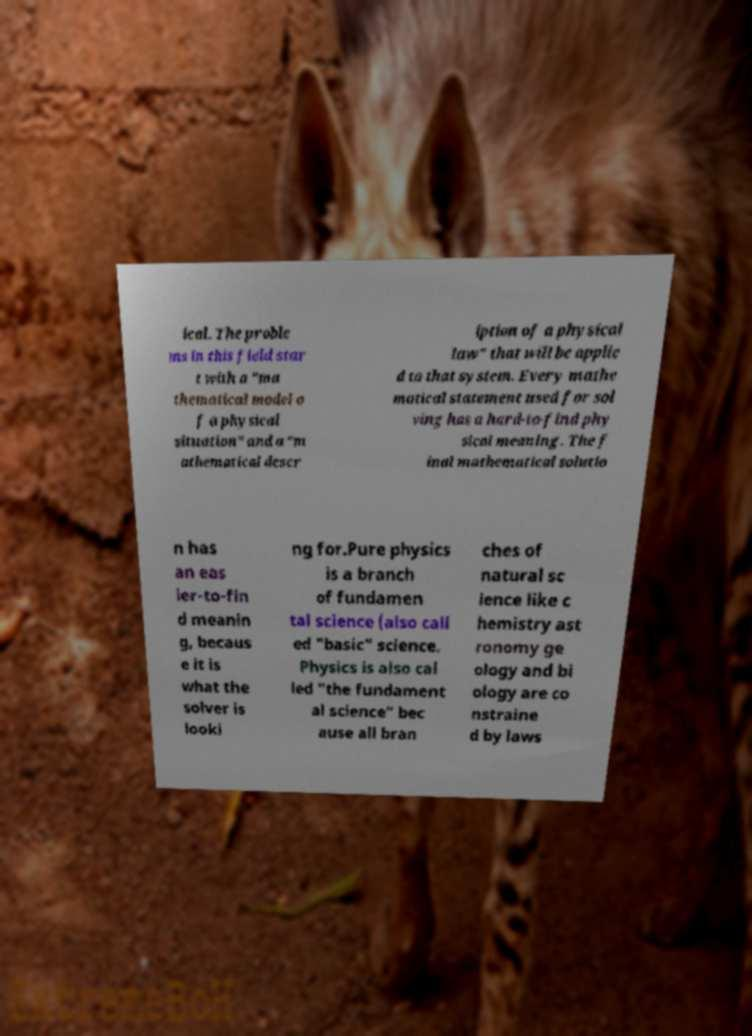Could you extract and type out the text from this image? ical. The proble ms in this field star t with a "ma thematical model o f a physical situation" and a "m athematical descr iption of a physical law" that will be applie d to that system. Every mathe matical statement used for sol ving has a hard-to-find phy sical meaning. The f inal mathematical solutio n has an eas ier-to-fin d meanin g, becaus e it is what the solver is looki ng for.Pure physics is a branch of fundamen tal science (also call ed "basic" science. Physics is also cal led "the fundament al science" bec ause all bran ches of natural sc ience like c hemistry ast ronomy ge ology and bi ology are co nstraine d by laws 